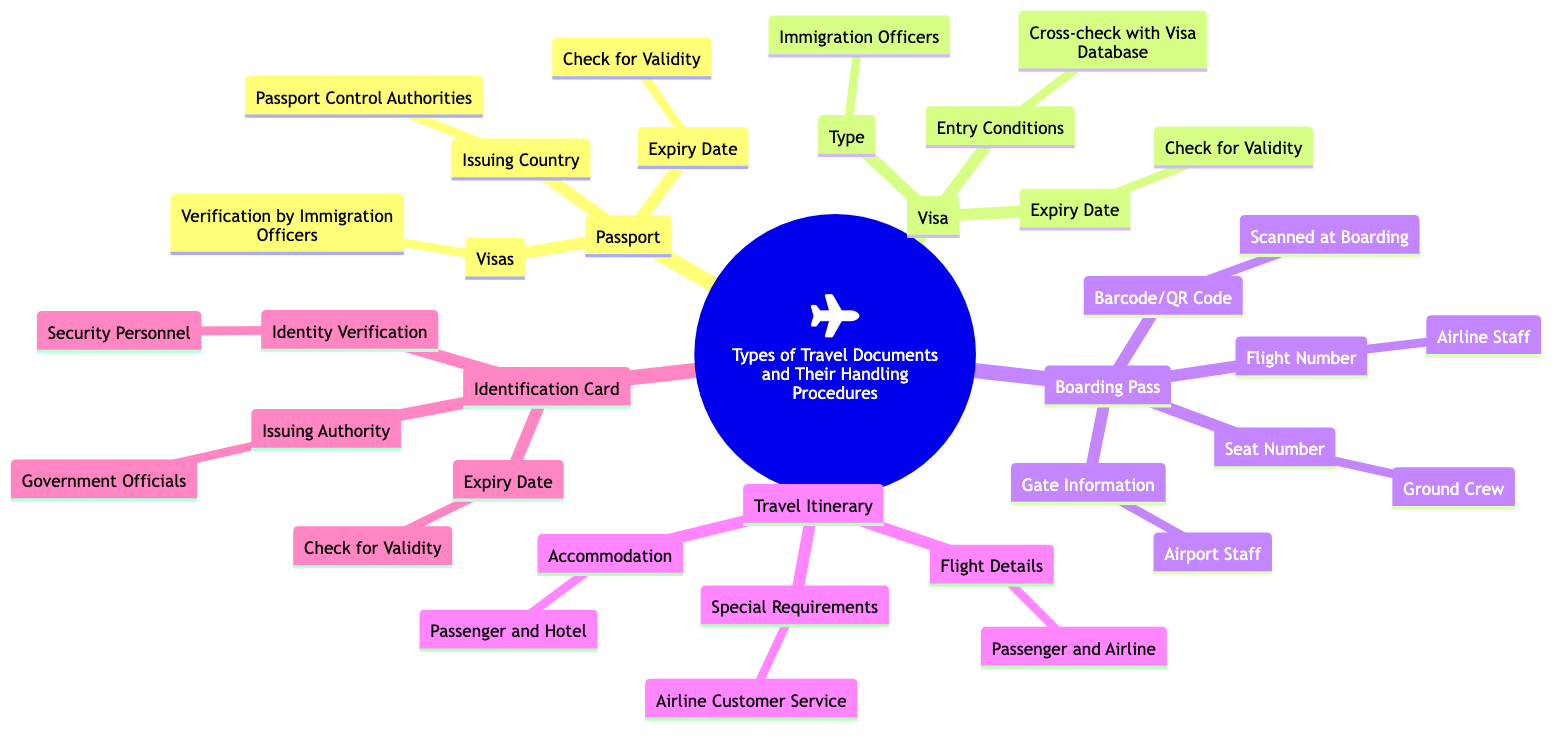What type of travel document includes "Flight Number"? The "Flight Number" is a sub-element under the "Boarding Pass" category in the diagram. This is clearly labeled in the visual representation.
Answer: Boarding Pass Who handles the "Expiry Date" check for Visa? The "Expiry Date" for Visa is managed by the "Check for Validity" note under the "Visa" type in the diagram. This indicates that validity checks are a standardized procedure.
Answer: Check for Validity What is the main authority responsible for issuing Identification Cards? The "Issuing Authority" for Identification Cards is specified as "Government Officials" in the diagram, indicating their role in the issuance process.
Answer: Government Officials How many main types of travel documents are listed in the diagram? The diagram includes five main types of travel documents: Passport, Visa, Boarding Pass, Travel Itinerary, and Identification Card, which can be counted directly from the visual layout.
Answer: Five What element is associated with "Verification by Immigration Officers"? The "Verification by Immigration Officers" is associated with the "Visas" sub-element under the "Visa" category. This connection is clearly laid out in the diagram, linking the procedure with the type of document.
Answer: Visas Which travel document involves Airline Customer Service for handling special requirements? The "Airline Customer Service" is related to special requirements under the "Travel Itinerary" type. This shows the collaborative role of airline staff in managing passenger needs.
Answer: Travel Itinerary How many handling authorities are involved with the Boarding Pass? There are four handling authorities indicated for the Boarding Pass: Airline Staff, Airport Staff, Ground Crew, and Scanned at Boarding. This can be easily verified by counting the connected nodes in the Boarding Pass section.
Answer: Four What document requires cross-checking with a database for entry conditions? The entry conditions that require cross-checking with a database are relevant to the "Visa" document in the diagram. It explicitly connects the handling procedure to the type of document.
Answer: Visa Which handling authority checks the "Issuing Country" for a Passport? The "Issuing Country" for a Passport is handled by "Passport Control Authorities" as noted in the diagram. This establishes their role in passport verification.
Answer: Passport Control Authorities 